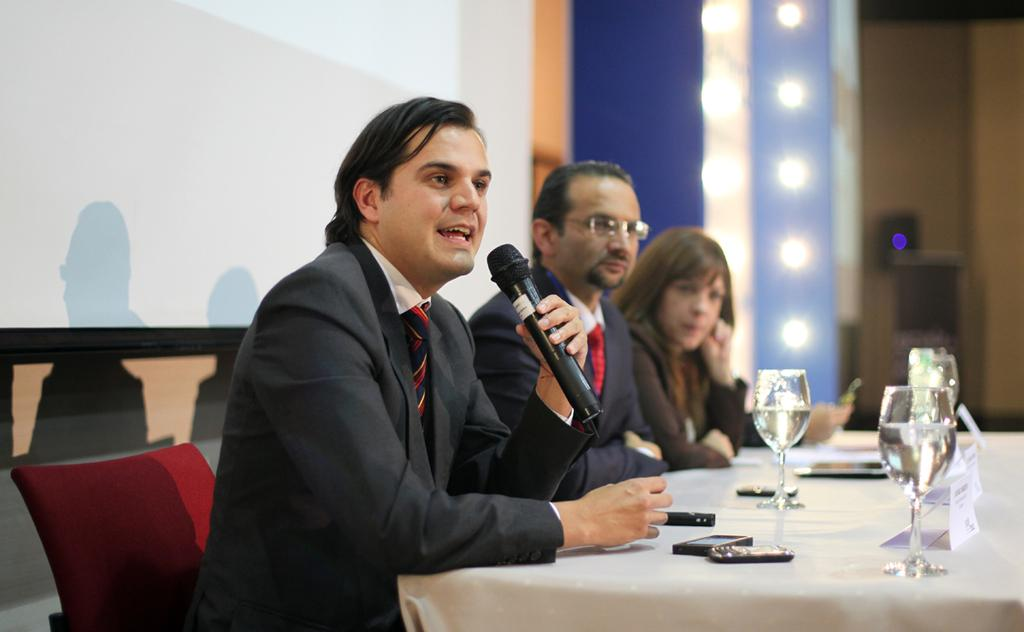What is the man on the left side of the image doing? The man is sitting on a chair and speaking into a microphone. What is the man wearing in the image? The man is wearing a coat. What objects can be seen on the table in the image? There are glasses on a table in the image. How many other people are present in the image besides the man on the left side? There is another man and a woman in the image. What type of pest can be seen crawling on the night sky in the image? There is no pest or night sky present in the image; it features a man sitting on a chair and speaking into a microphone, along with other people and objects. 